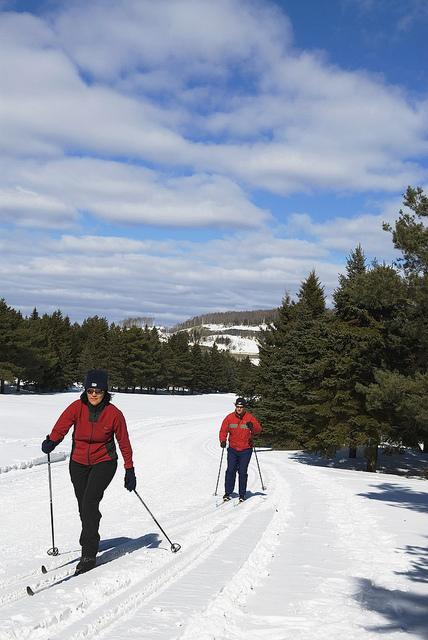What action are the people taking? skiing 